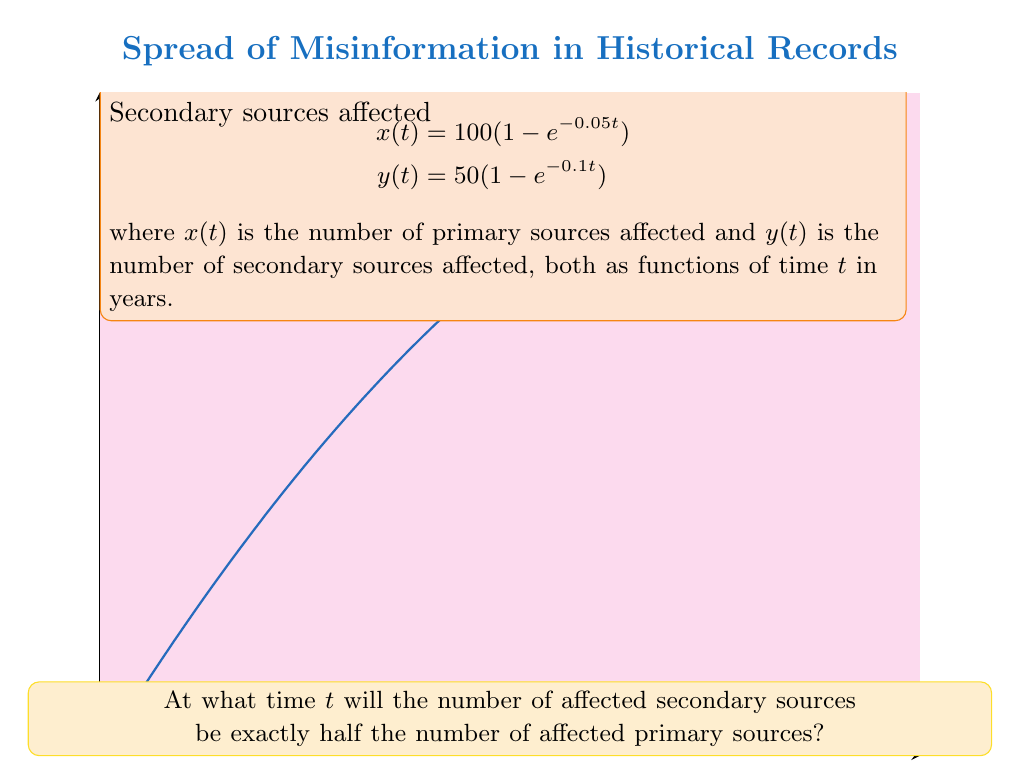Teach me how to tackle this problem. Let's approach this step-by-step:

1) We need to find $t$ where $y(t) = \frac{1}{2}x(t)$. Let's set up this equation:

   $$50(1 - e^{-0.1t}) = \frac{1}{2} \cdot 100(1 - e^{-0.05t})$$

2) Simplify the right side:

   $$50(1 - e^{-0.1t}) = 50(1 - e^{-0.05t})$$

3) The 50 cancels out on both sides:

   $$1 - e^{-0.1t} = 1 - e^{-0.05t}$$

4) Subtract 1 from both sides:

   $$-e^{-0.1t} = -e^{-0.05t}$$

5) Multiply both sides by -1:

   $$e^{-0.1t} = e^{-0.05t}$$

6) Take the natural log of both sides:

   $$-0.1t = -0.05t$$

7) Subtract -0.05t from both sides:

   $$-0.05t = 0$$

8) Divide both sides by -0.05:

   $$t = 0$$

This result shows that the condition is met only at $t=0$, which represents the initial state where no sources are affected. As $t$ increases, the ratio between secondary and primary sources changes continuously, never again reaching exactly 1:2.

For a non-trivial solution, we could ask when the ratio is approximately 1:2. However, the exact 1:2 ratio only occurs at $t=0$ in this model.
Answer: $t = 0$ 